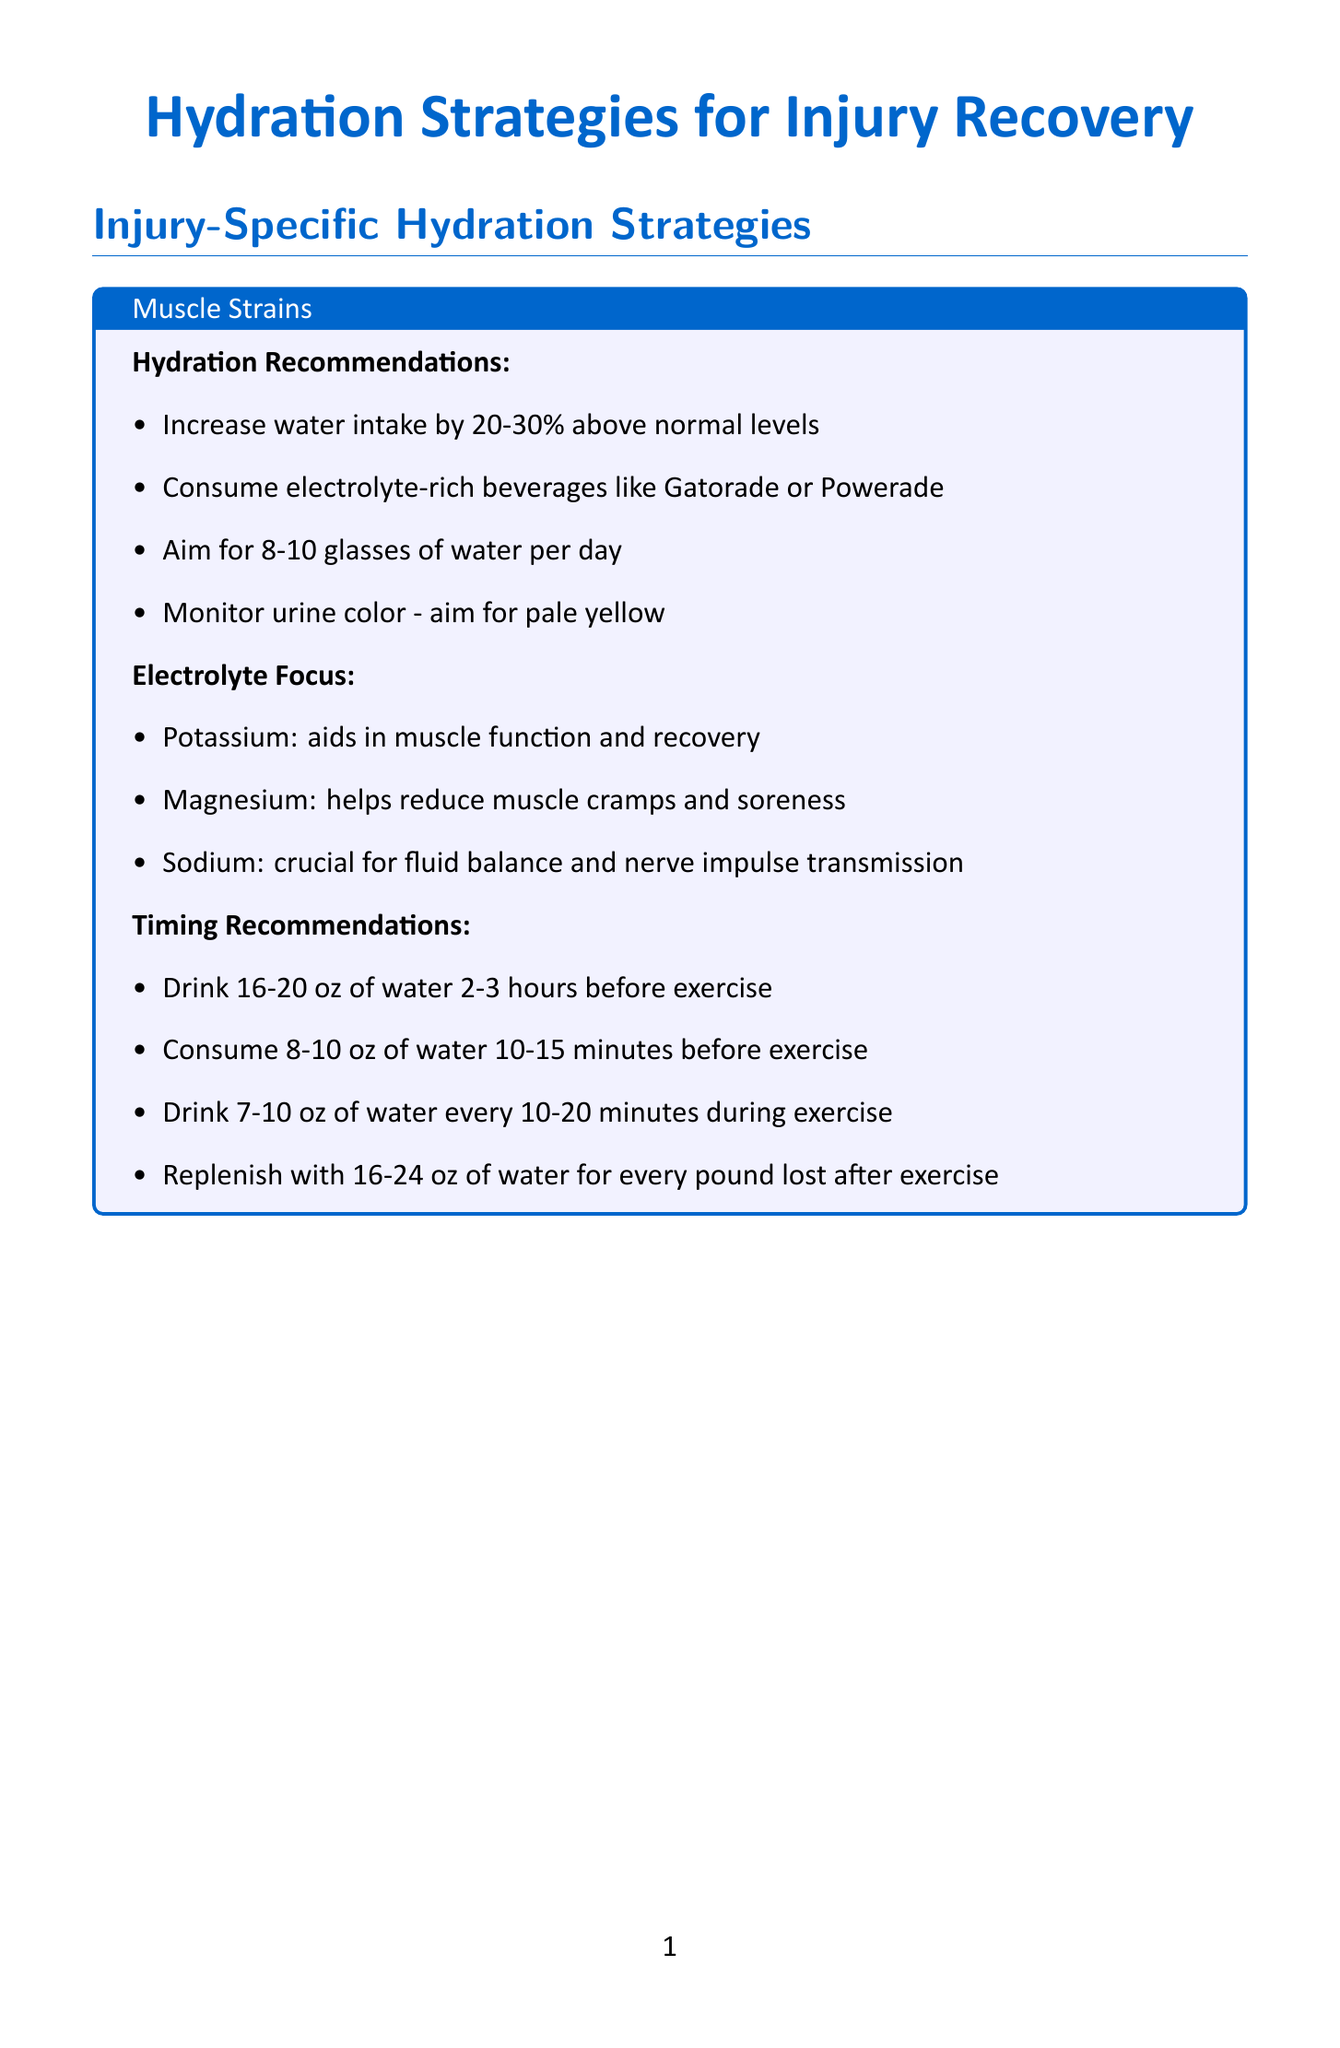What is the recommended water intake for muscle strains? The document states to aim for 8-10 glasses of water per day for muscle strains.
Answer: 8-10 glasses Which beverage is recommended for bone fractures? The document suggests including calcium-rich beverages like milk or fortified plant-based alternatives.
Answer: Calcium-rich beverages What electrolyte is crucial for fluid balance? Sodium is noted as crucial for fluid balance and nerve impulse transmission in the document.
Answer: Sodium When should tart cherry juice be consumed for ligament sprains? The timing recommendation is to drink tart cherry juice 30 minutes before bedtime for recovery.
Answer: 30 minutes before bedtime What is a hydration myth regarding caffeine? The document states that the myth is that caffeine always leads to dehydration, which is then debunked.
Answer: Caffeine always leads to dehydration Which product is low in calories and easy to carry? Nuun Sport Electrolyte Tablets are mentioned as low in calories and easy to carry.
Answer: Nuun Sport Electrolyte Tablets What is the finding from the Journal of Athletic Training in 2017? The finding states that proper hydration can reduce the risk of heat illness and improve performance during rehabilitation exercises.
Answer: Proper hydration can reduce the risk of heat illness and improve performance What is the primary focus of electrolyte balance for ligament sprains? The focus is on Vitamin C, which supports collagen production for ligament repair.
Answer: Vitamin C 